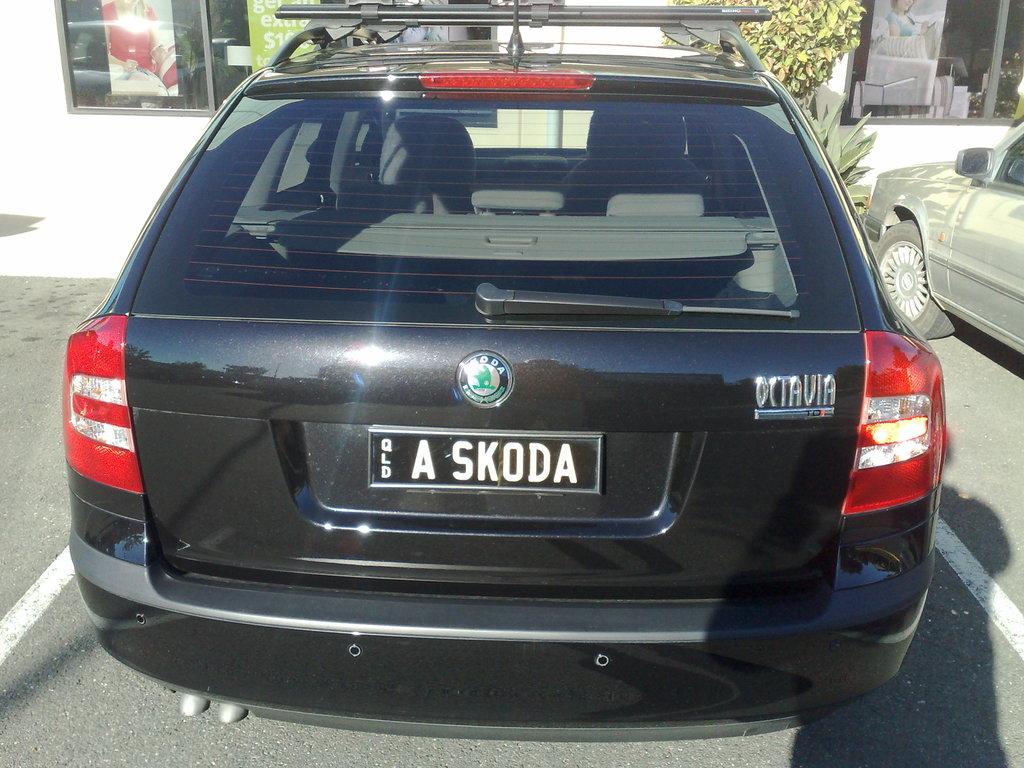What is them emblem on the car?
Your answer should be very brief. Unanswerable. What is written on this licence plate? (do not include "qld")?
Ensure brevity in your answer.  A skoda. 